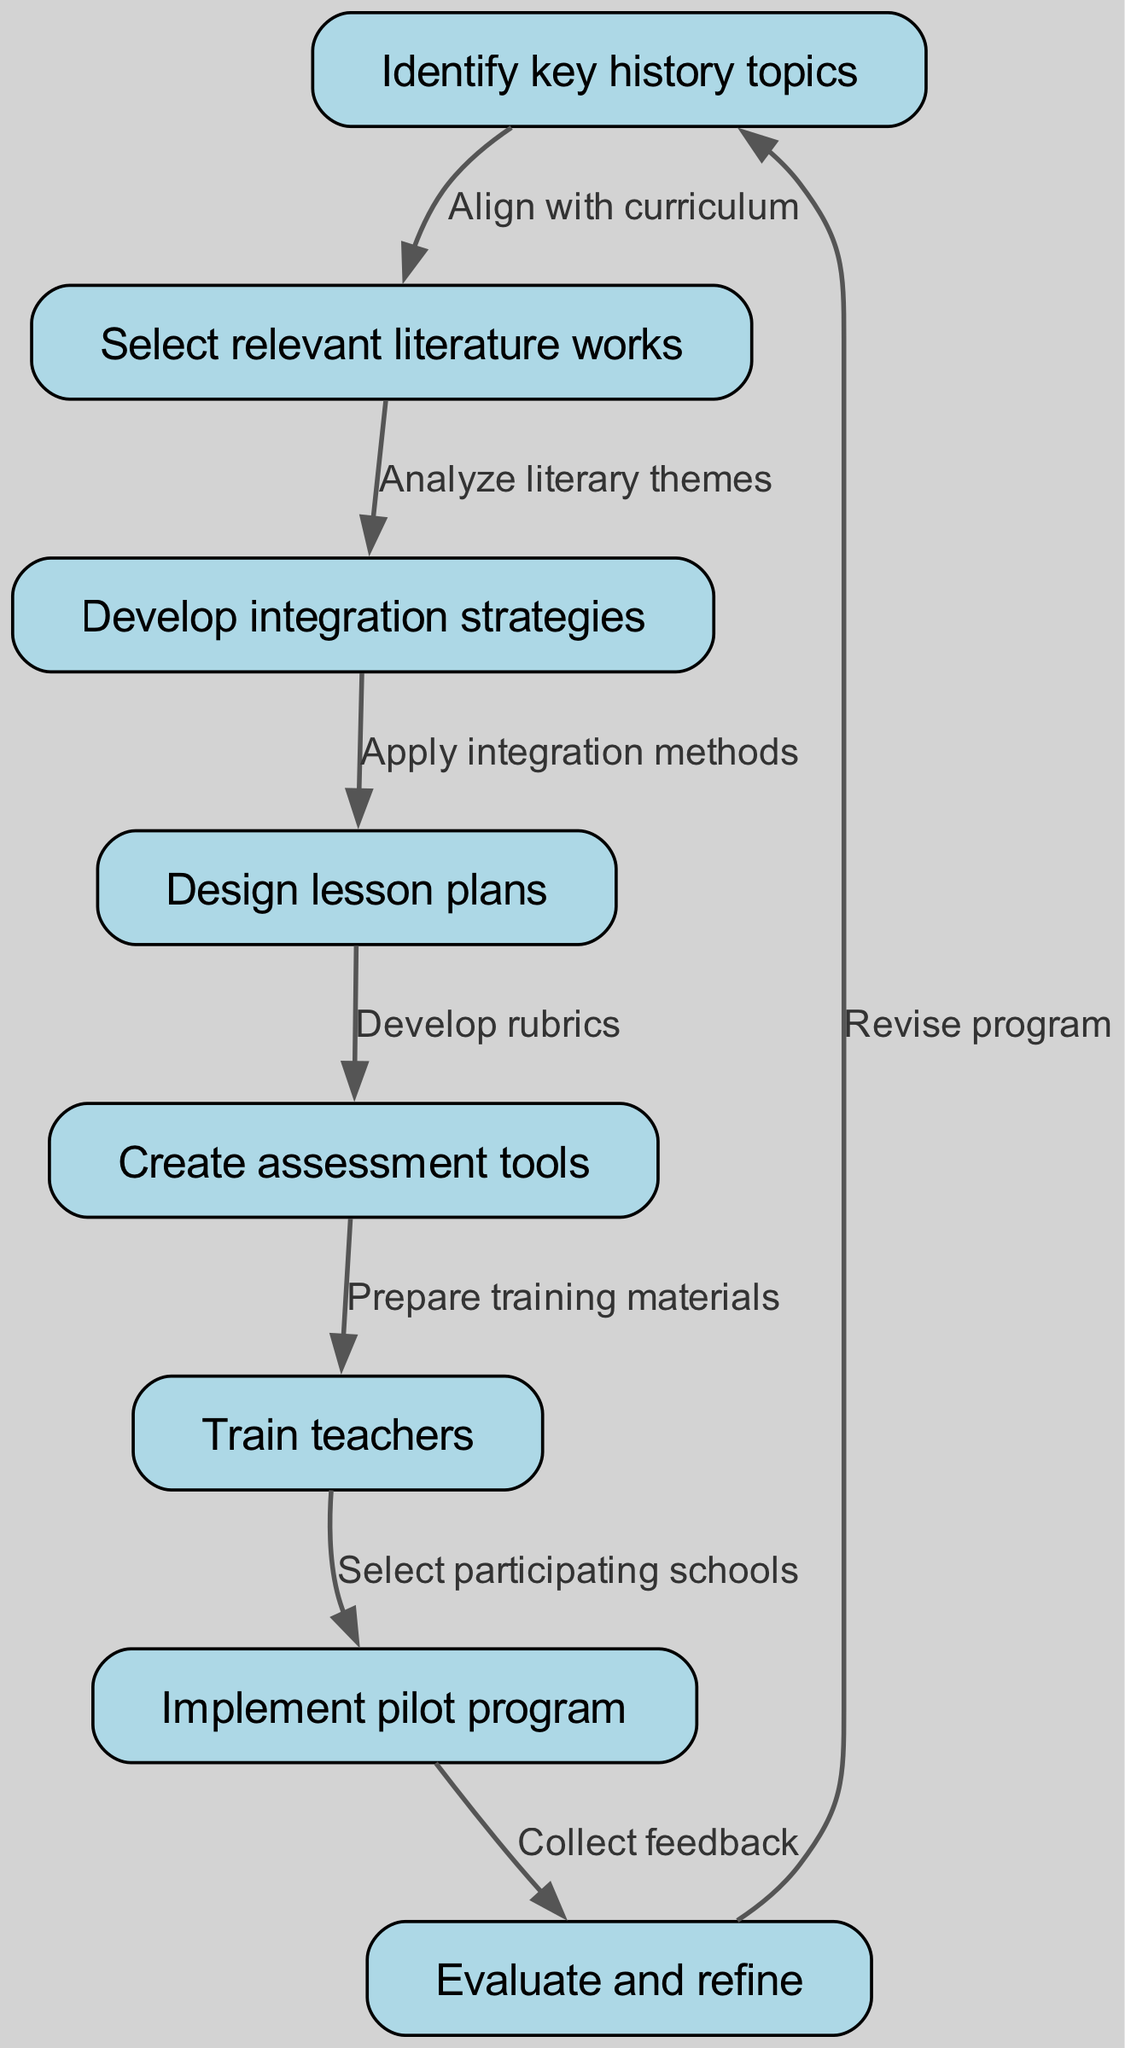What is the first step in the clinical pathway? The first node in the diagram is labeled "Identify key history topics," indicating that this is the initial step in the clinical pathway.
Answer: Identify key history topics How many nodes are present in the clinical pathway? By counting each distinct node listed, we find there are eight nodes total in the diagram.
Answer: 8 What is the relationship between "Select relevant literature works" and "Develop integration strategies"? The edge connects node two "Select relevant literature works" to node three "Develop integration strategies," indicating that selecting literature informs the development of integration strategies.
Answer: Analyze literary themes Which node directly follows "Create assessment tools"? The edge leads from node five "Create assessment tools" to node six "Train teachers," making it the next step in the pathway.
Answer: Train teachers What step involves gathering feedback? The last node before reverting to the first is "Evaluate and refine," where collecting feedback is implied as part of the evaluation process.
Answer: Collect feedback What is the purpose of the edge connecting "Design lesson plans" and "Create assessment tools"? The edge represents the development of rubrics, signifying that lesson plans inform the creation of assessment tools.
Answer: Develop rubrics How does the implementation phase relate to the prior steps? The node "Implement pilot program" (node seven) comes after "Train teachers," indicating that implementation follows teacher training. This shows that teacher training is a prerequisite for the pilot program.
Answer: Train teachers What is the final action described in the clinical pathway before it loops back? The pathway describes the action "Revise program," which signifies the final step before returning to "Identify key history topics," indicating a process of continuous improvement.
Answer: Revise program 